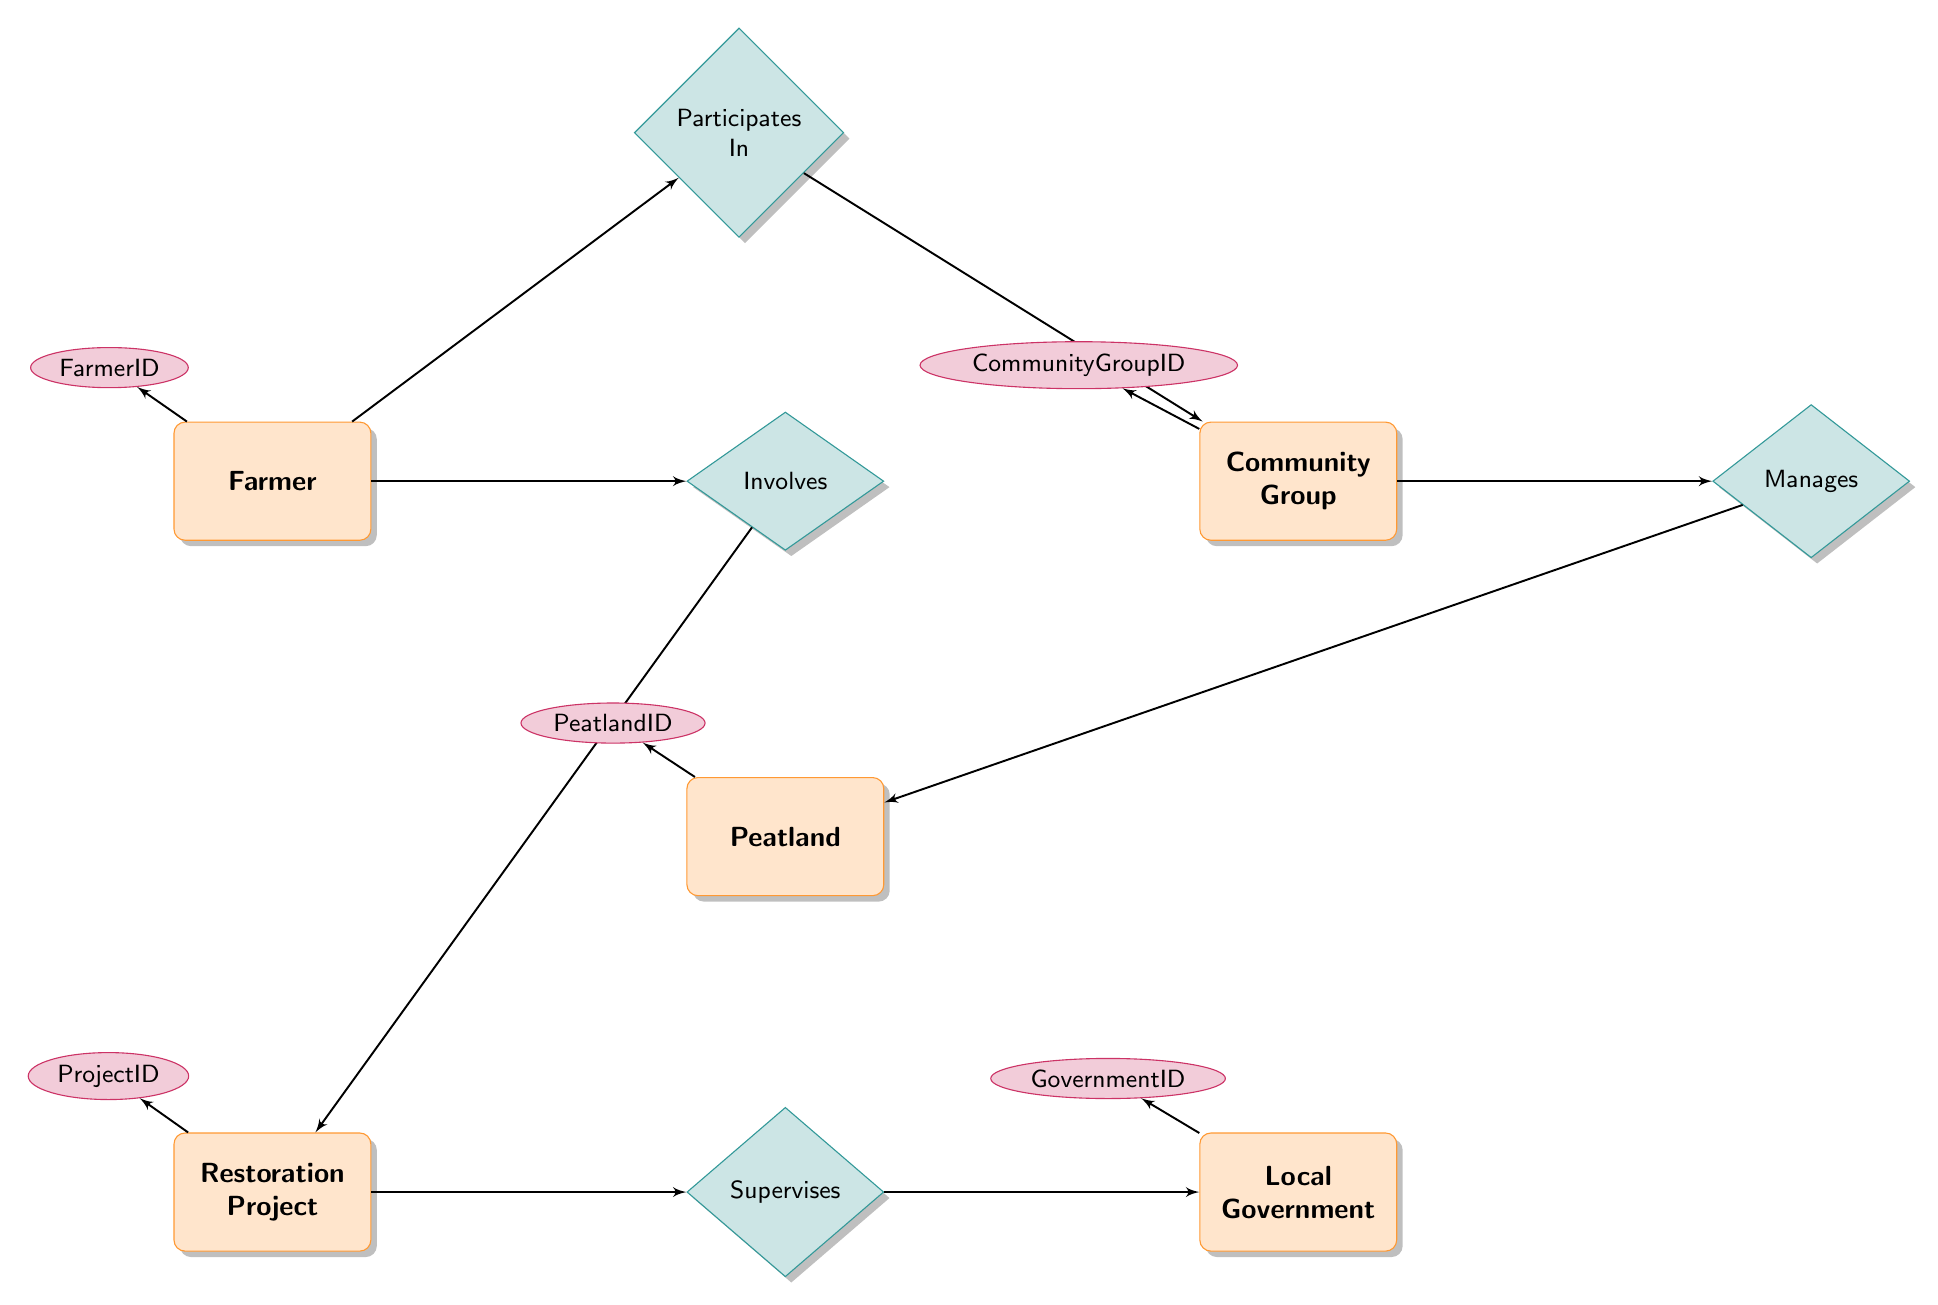What entities are present in the diagram? The diagram contains five entities: Farmer, Peatland, Community Group, Restoration Project, and Local Government.
Answer: Farmer, Peatland, Community Group, Restoration Project, Local Government How many relationships are there in the diagram? The diagram has four relationships: Involves, Supervises, Manages, and Participates In.
Answer: Four Which entity is supervised by Local Government? According to the diagram, the entity that is supervised by Local Government is the Restoration Project.
Answer: Restoration Project What role does a Farmer have in a Restoration Project? In the diagram, the relationship between Farmer and Restoration Project specifies a role that the Farmer has in the project, described by the relationship "Involves."
Answer: Role Who manages the Peatland? The Peatland is managed by the Community Group, as represented in the relationship "Manages" in the diagram.
Answer: Community Group What is the connection between Farmer and Community Group? The connection between Farmer and Community Group is established through the "Participates In" relationship, indicating that Farmers can be part of Community Groups.
Answer: Participates In What does the Community Group do? The Community Group is responsible for managing Peatland, as indicated by its relationship with the Peatland entity.
Answer: Manages What does Local Government supervise? The Local Government supervises the Restoration Project as shown in the "Supervises" relationship connecting both entities.
Answer: Restoration Project When does the participation of a Farmer in Community Group begin? The diagram shows that participation between Farmer and Community Group is marked by an attribute "JoinDate," indicating when the Farmer joins the Community Group.
Answer: JoinDate 